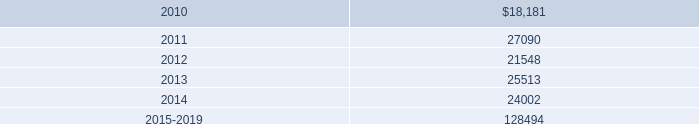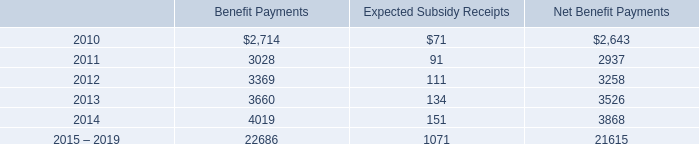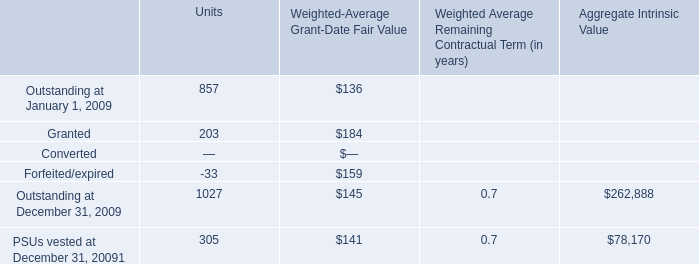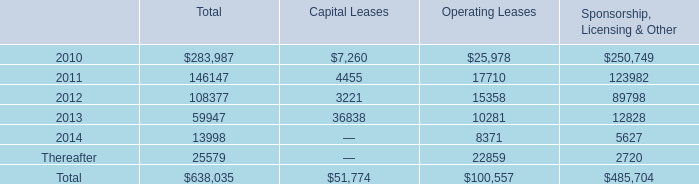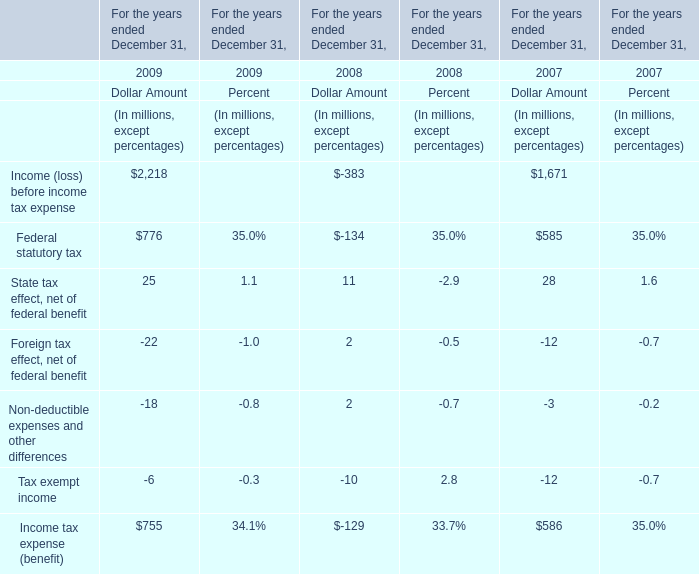what is the average contribution expense related to all of its defined contribution plans for the years 2007-2009? 
Computations: ((26996 + (40627 + 35341)) / 3)
Answer: 34321.33333. 